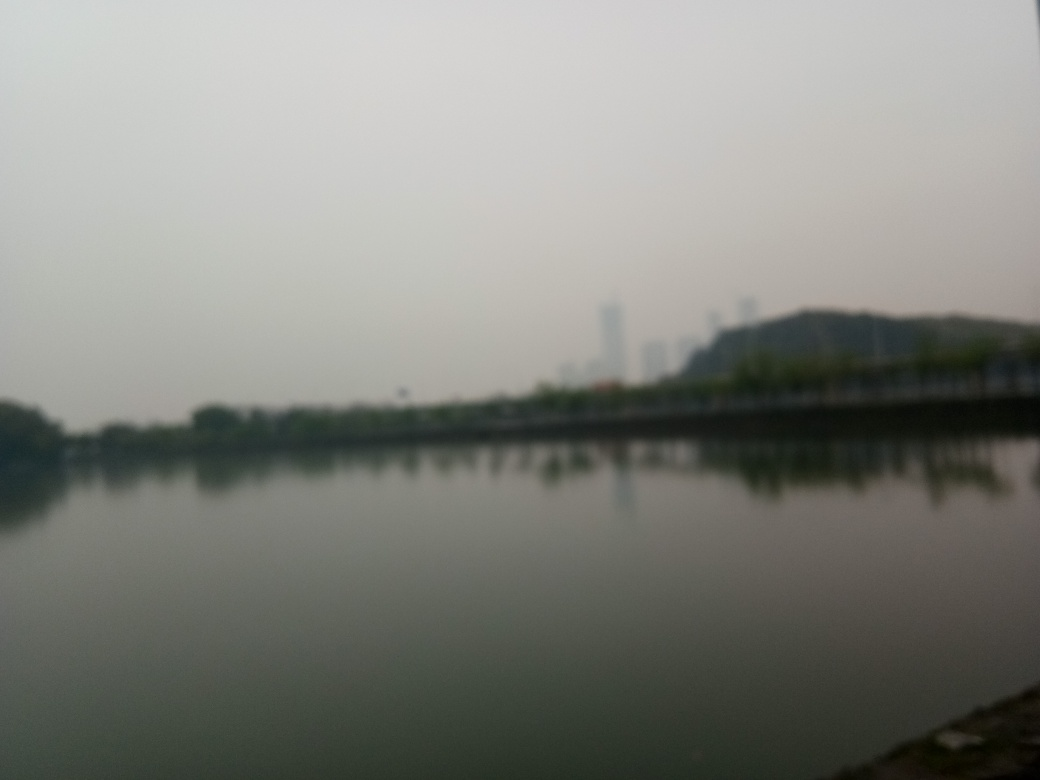Is the image properly exposed? The original VQA response indicated option 'B' (No), suggesting the image is not properly exposed, which seems accurate upon examination. The photograph displays poor visibility due to underexposure and lacks contrast, details, and clarity. This makes it challenging to identify features or subjects in the scene, resulting in a flat and dull appearance. 